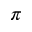<formula> <loc_0><loc_0><loc_500><loc_500>\pi</formula> 